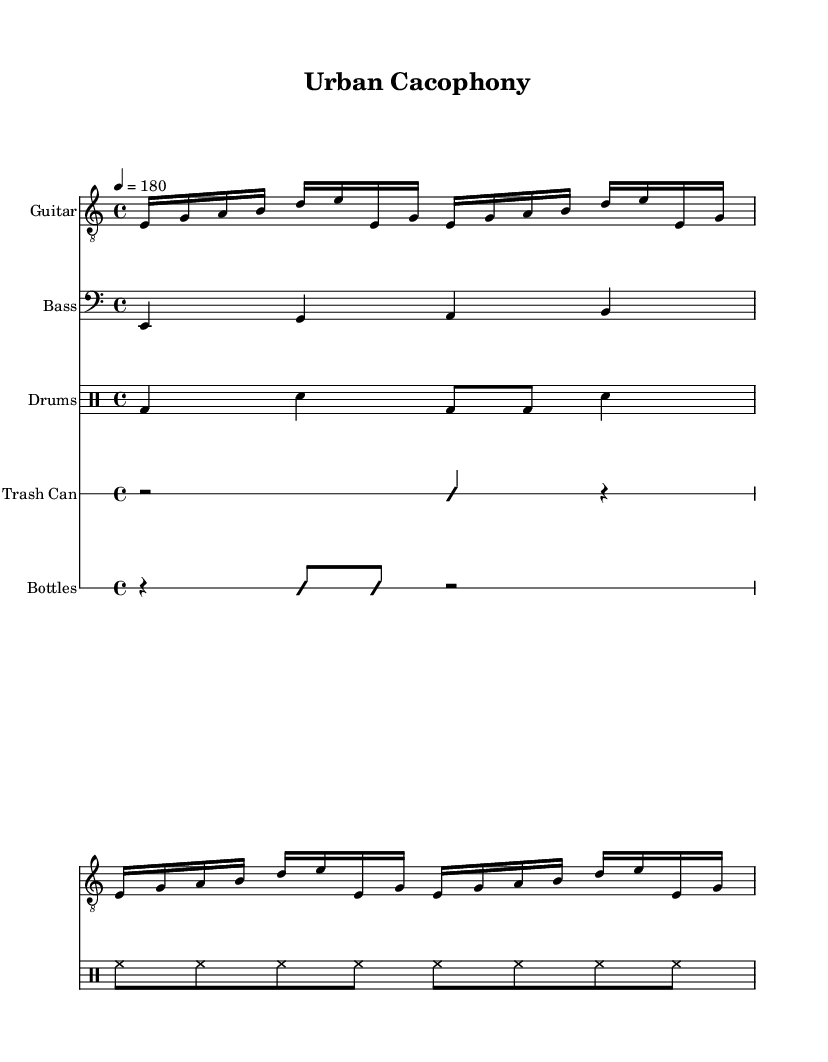What is the time signature of this music? The time signature is located at the beginning of the score, indicated by the "4/4" notation. This means there are four beats in each measure.
Answer: 4/4 What is the tempo marking for this piece? The tempo marking, which indicates the speed of the music, is shown as "4 = 180". This means there are 180 quarter note beats per minute.
Answer: 180 How many measures does the guitar riff repeat? The guitar riff section has a "repeat unfold" marking that indicates it repeats four times. This can be deduced from the notation in the section where the guitar riff is written.
Answer: 4 What kind of unconventional instrument is used in this piece? In the score, there are indications for unconventional instruments such as "Trash Can" and "Bottles." The presence of these instruments signifies their inclusion in the arrangement.
Answer: Trash Can, Bottles What is the style of the drum pattern presented in this sheet music? The drum pattern follows a straightforward rock style, as indicated by the bass drum and snare combination along with consistent hi-hat rhythms. This structure reflects common elements found in punk music.
Answer: Punk Rock What type of notation is used for the glass bottles part? The notation for the glass bottles section is indicated with an "improvisationOn" marking, suggesting that it includes free, unconventional rhythmic patterns, a characteristic trait of noise punk.
Answer: Improvisational What is the key signature of this music? The piece does not have any sharps or flats indicated at the beginning, which suggests that it is in the key of C major.
Answer: C major 